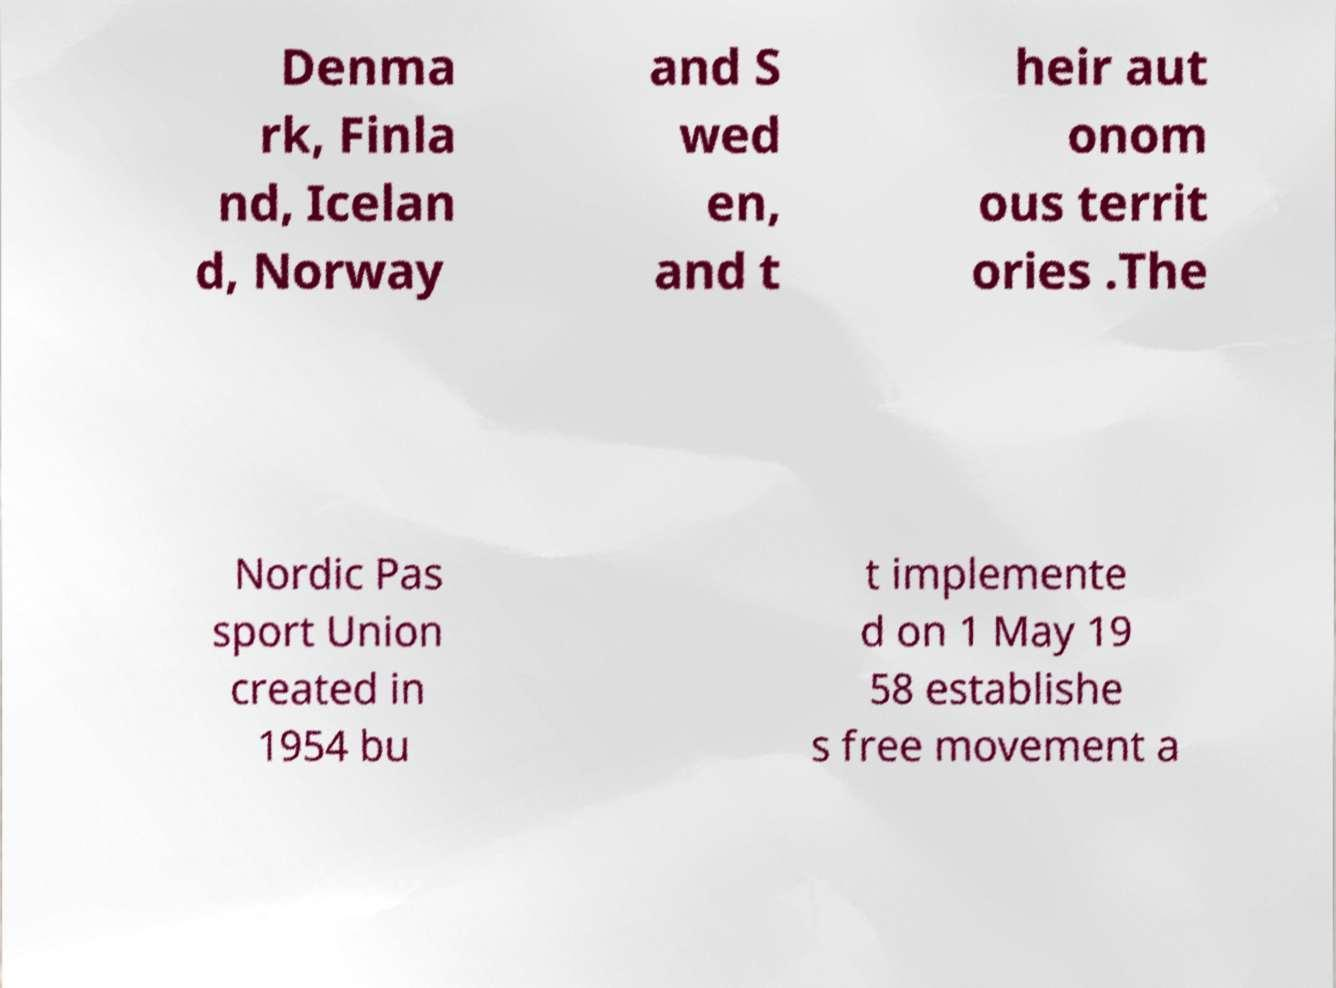Please identify and transcribe the text found in this image. Denma rk, Finla nd, Icelan d, Norway and S wed en, and t heir aut onom ous territ ories .The Nordic Pas sport Union created in 1954 bu t implemente d on 1 May 19 58 establishe s free movement a 